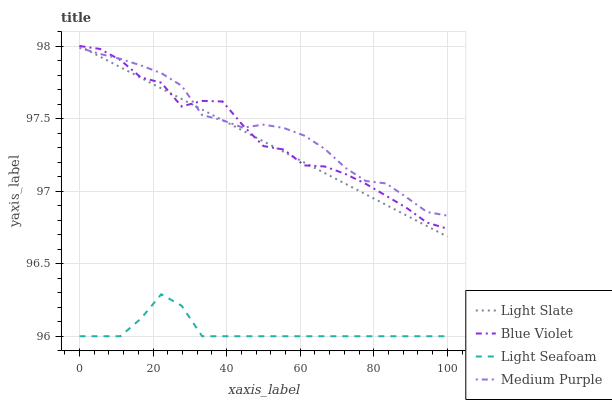Does Medium Purple have the minimum area under the curve?
Answer yes or no. No. Does Light Seafoam have the maximum area under the curve?
Answer yes or no. No. Is Medium Purple the smoothest?
Answer yes or no. No. Is Medium Purple the roughest?
Answer yes or no. No. Does Medium Purple have the lowest value?
Answer yes or no. No. Does Medium Purple have the highest value?
Answer yes or no. No. Is Light Seafoam less than Light Slate?
Answer yes or no. Yes. Is Blue Violet greater than Light Seafoam?
Answer yes or no. Yes. Does Light Seafoam intersect Light Slate?
Answer yes or no. No. 